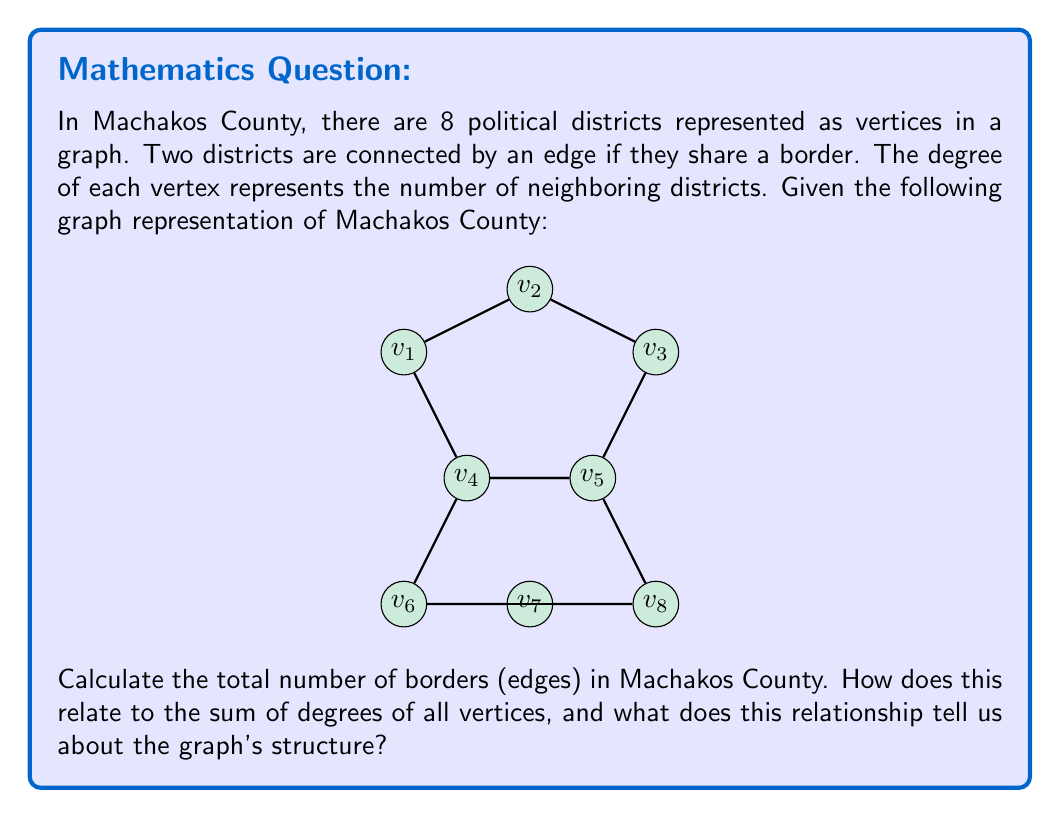Solve this math problem. Let's approach this step-by-step:

1) First, let's count the degree of each vertex:
   $deg(v_1) = 2$, $deg(v_2) = 2$, $deg(v_3) = 2$, $deg(v_4) = 4$,
   $deg(v_5) = 4$, $deg(v_6) = 2$, $deg(v_7) = 3$, $deg(v_8) = 3$

2) The sum of all degrees is:
   $$\sum_{i=1}^8 deg(v_i) = 2 + 2 + 2 + 4 + 4 + 2 + 3 + 3 = 22$$

3) In graph theory, there's a fundamental theorem known as the Handshaking Lemma, which states that for any undirected graph:

   $$\sum_{v \in V} deg(v) = 2|E|$$

   where $V$ is the set of vertices and $E$ is the set of edges.

4) This is because each edge contributes 2 to the sum of degrees (one for each endpoint).

5) Using this theorem, we can find the number of edges:

   $$22 = 2|E|$$
   $$|E| = 11$$

6) Therefore, there are 11 borders (edges) in Machakos County.

7) The relationship between the sum of degrees (22) and the number of edges (11) confirms that this is indeed a simple, undirected graph without self-loops or multiple edges between the same pair of vertices. This structure is typical for geographical representations where each edge represents a physical border between two districts.
Answer: 11 edges; sum of degrees = 2 * number of edges, confirming simple undirected graph structure 